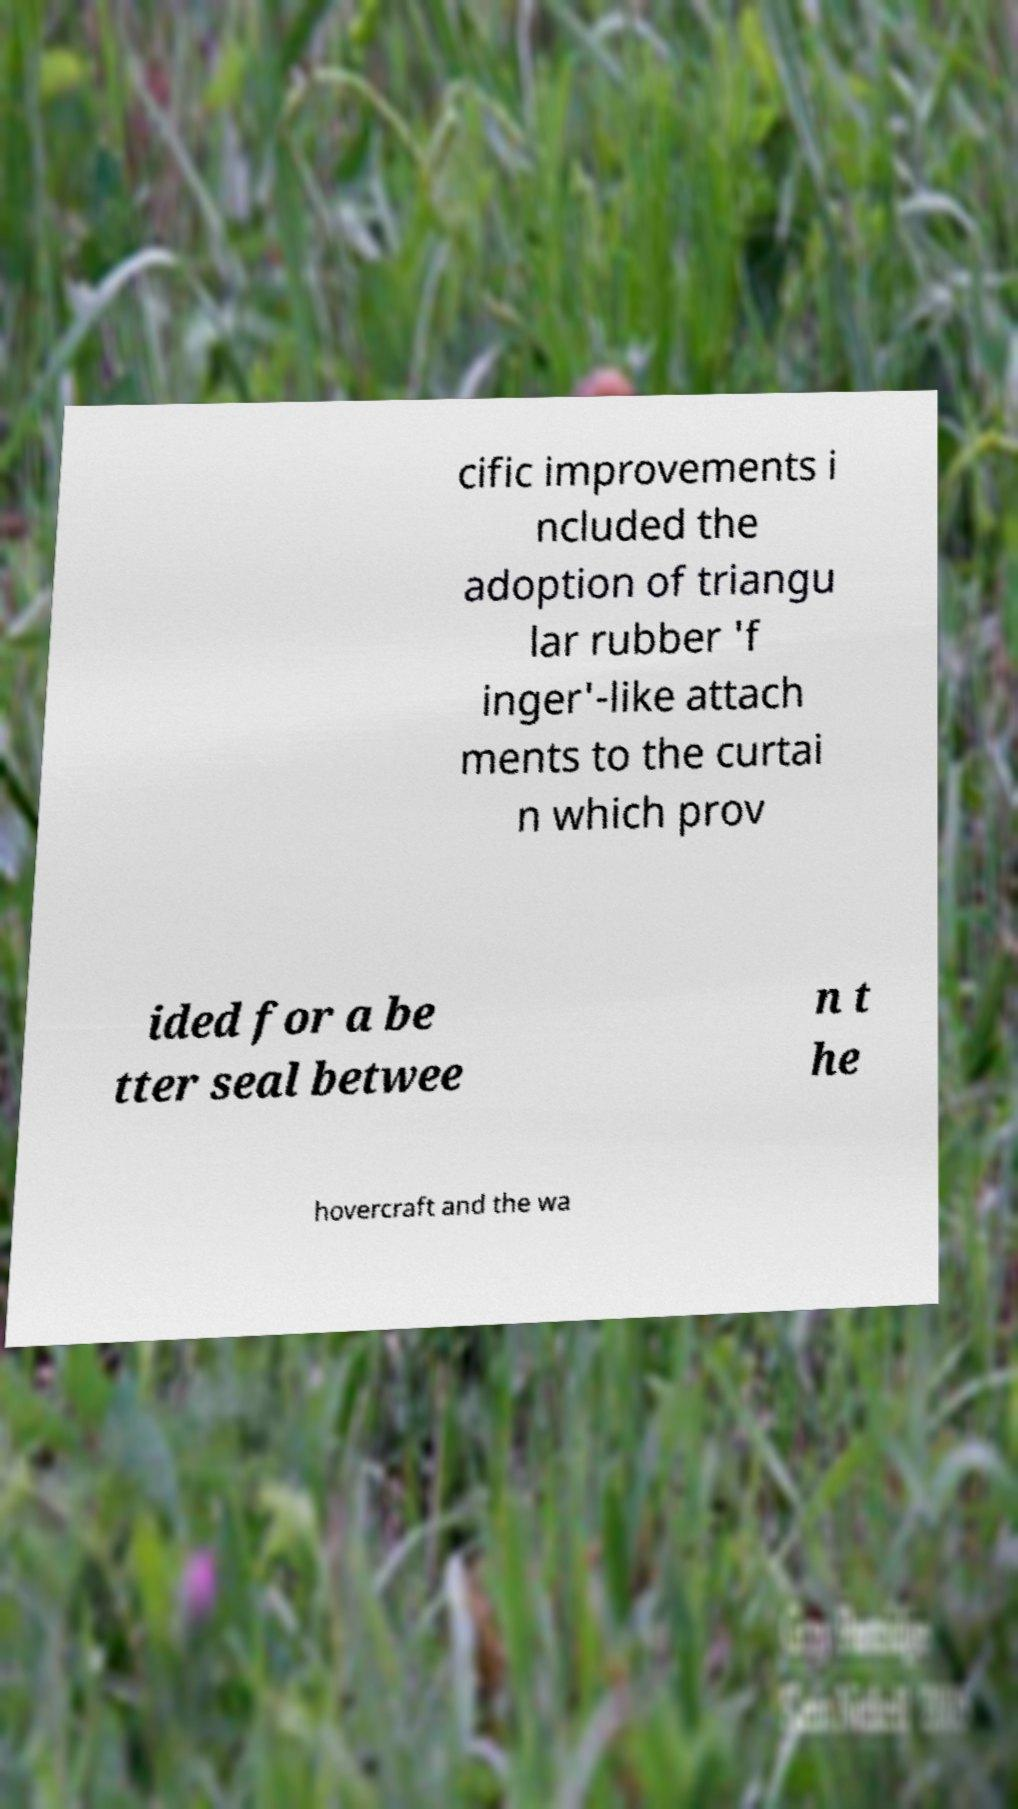Please read and relay the text visible in this image. What does it say? cific improvements i ncluded the adoption of triangu lar rubber 'f inger'-like attach ments to the curtai n which prov ided for a be tter seal betwee n t he hovercraft and the wa 